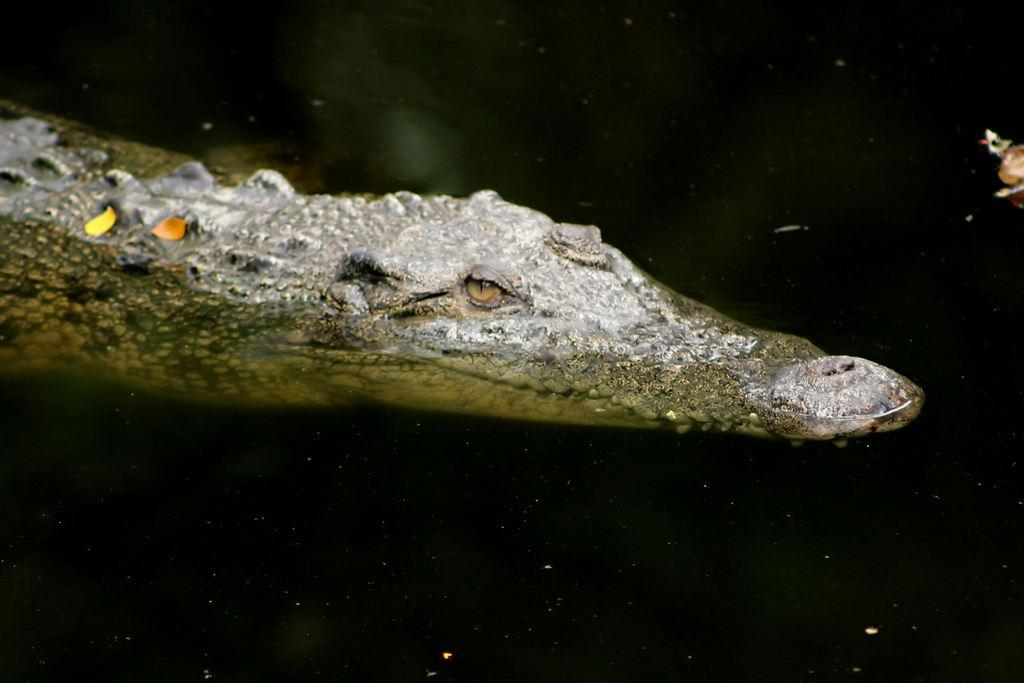What animal is in the water in the image? There is a crocodile in the water. What else can be seen floating on the water? There are leaves on the water. Where is the window located in the image? There is no window present in the image; it features a crocodile in the water and leaves on the water. What type of receipt can be seen in the image? There is no receipt present in the image. 